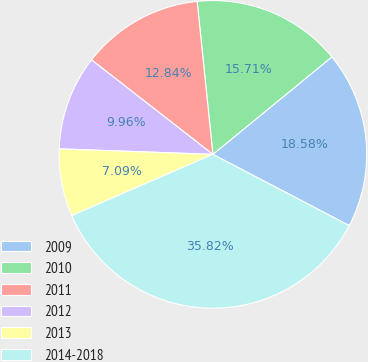Convert chart to OTSL. <chart><loc_0><loc_0><loc_500><loc_500><pie_chart><fcel>2009<fcel>2010<fcel>2011<fcel>2012<fcel>2013<fcel>2014-2018<nl><fcel>18.58%<fcel>15.71%<fcel>12.84%<fcel>9.96%<fcel>7.09%<fcel>35.82%<nl></chart> 